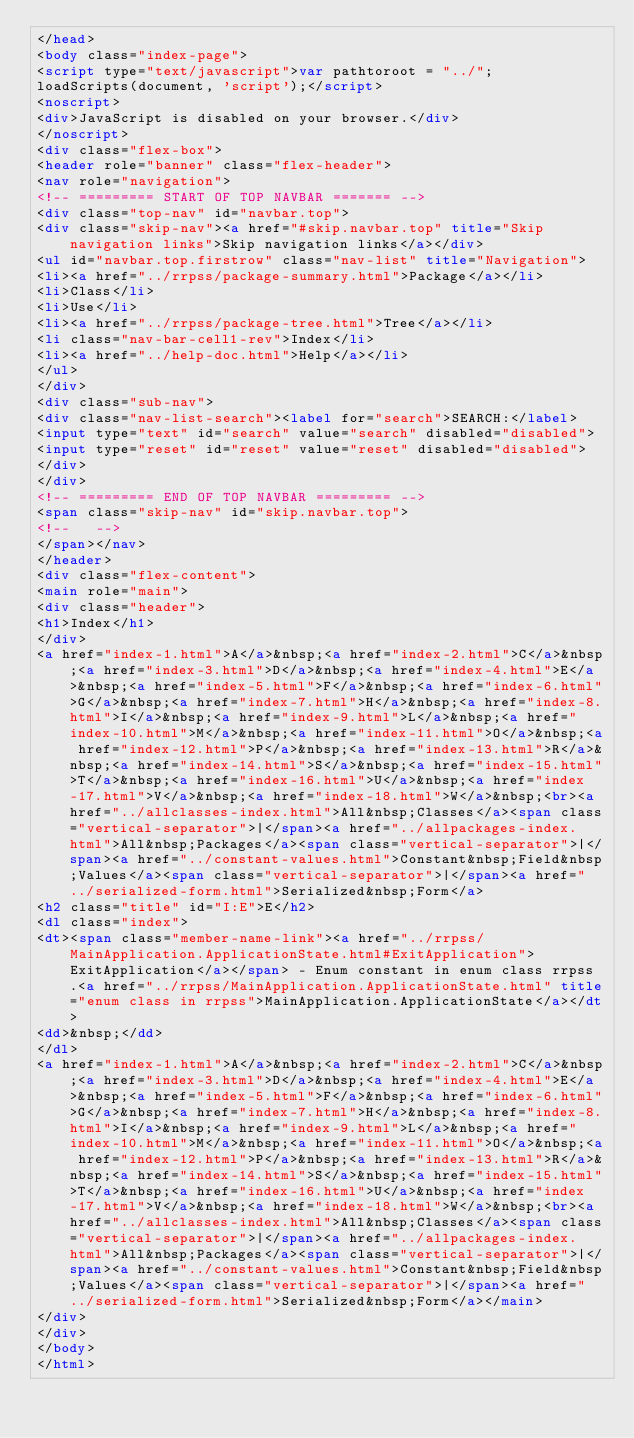Convert code to text. <code><loc_0><loc_0><loc_500><loc_500><_HTML_></head>
<body class="index-page">
<script type="text/javascript">var pathtoroot = "../";
loadScripts(document, 'script');</script>
<noscript>
<div>JavaScript is disabled on your browser.</div>
</noscript>
<div class="flex-box">
<header role="banner" class="flex-header">
<nav role="navigation">
<!-- ========= START OF TOP NAVBAR ======= -->
<div class="top-nav" id="navbar.top">
<div class="skip-nav"><a href="#skip.navbar.top" title="Skip navigation links">Skip navigation links</a></div>
<ul id="navbar.top.firstrow" class="nav-list" title="Navigation">
<li><a href="../rrpss/package-summary.html">Package</a></li>
<li>Class</li>
<li>Use</li>
<li><a href="../rrpss/package-tree.html">Tree</a></li>
<li class="nav-bar-cell1-rev">Index</li>
<li><a href="../help-doc.html">Help</a></li>
</ul>
</div>
<div class="sub-nav">
<div class="nav-list-search"><label for="search">SEARCH:</label>
<input type="text" id="search" value="search" disabled="disabled">
<input type="reset" id="reset" value="reset" disabled="disabled">
</div>
</div>
<!-- ========= END OF TOP NAVBAR ========= -->
<span class="skip-nav" id="skip.navbar.top">
<!--   -->
</span></nav>
</header>
<div class="flex-content">
<main role="main">
<div class="header">
<h1>Index</h1>
</div>
<a href="index-1.html">A</a>&nbsp;<a href="index-2.html">C</a>&nbsp;<a href="index-3.html">D</a>&nbsp;<a href="index-4.html">E</a>&nbsp;<a href="index-5.html">F</a>&nbsp;<a href="index-6.html">G</a>&nbsp;<a href="index-7.html">H</a>&nbsp;<a href="index-8.html">I</a>&nbsp;<a href="index-9.html">L</a>&nbsp;<a href="index-10.html">M</a>&nbsp;<a href="index-11.html">O</a>&nbsp;<a href="index-12.html">P</a>&nbsp;<a href="index-13.html">R</a>&nbsp;<a href="index-14.html">S</a>&nbsp;<a href="index-15.html">T</a>&nbsp;<a href="index-16.html">U</a>&nbsp;<a href="index-17.html">V</a>&nbsp;<a href="index-18.html">W</a>&nbsp;<br><a href="../allclasses-index.html">All&nbsp;Classes</a><span class="vertical-separator">|</span><a href="../allpackages-index.html">All&nbsp;Packages</a><span class="vertical-separator">|</span><a href="../constant-values.html">Constant&nbsp;Field&nbsp;Values</a><span class="vertical-separator">|</span><a href="../serialized-form.html">Serialized&nbsp;Form</a>
<h2 class="title" id="I:E">E</h2>
<dl class="index">
<dt><span class="member-name-link"><a href="../rrpss/MainApplication.ApplicationState.html#ExitApplication">ExitApplication</a></span> - Enum constant in enum class rrpss.<a href="../rrpss/MainApplication.ApplicationState.html" title="enum class in rrpss">MainApplication.ApplicationState</a></dt>
<dd>&nbsp;</dd>
</dl>
<a href="index-1.html">A</a>&nbsp;<a href="index-2.html">C</a>&nbsp;<a href="index-3.html">D</a>&nbsp;<a href="index-4.html">E</a>&nbsp;<a href="index-5.html">F</a>&nbsp;<a href="index-6.html">G</a>&nbsp;<a href="index-7.html">H</a>&nbsp;<a href="index-8.html">I</a>&nbsp;<a href="index-9.html">L</a>&nbsp;<a href="index-10.html">M</a>&nbsp;<a href="index-11.html">O</a>&nbsp;<a href="index-12.html">P</a>&nbsp;<a href="index-13.html">R</a>&nbsp;<a href="index-14.html">S</a>&nbsp;<a href="index-15.html">T</a>&nbsp;<a href="index-16.html">U</a>&nbsp;<a href="index-17.html">V</a>&nbsp;<a href="index-18.html">W</a>&nbsp;<br><a href="../allclasses-index.html">All&nbsp;Classes</a><span class="vertical-separator">|</span><a href="../allpackages-index.html">All&nbsp;Packages</a><span class="vertical-separator">|</span><a href="../constant-values.html">Constant&nbsp;Field&nbsp;Values</a><span class="vertical-separator">|</span><a href="../serialized-form.html">Serialized&nbsp;Form</a></main>
</div>
</div>
</body>
</html>
</code> 